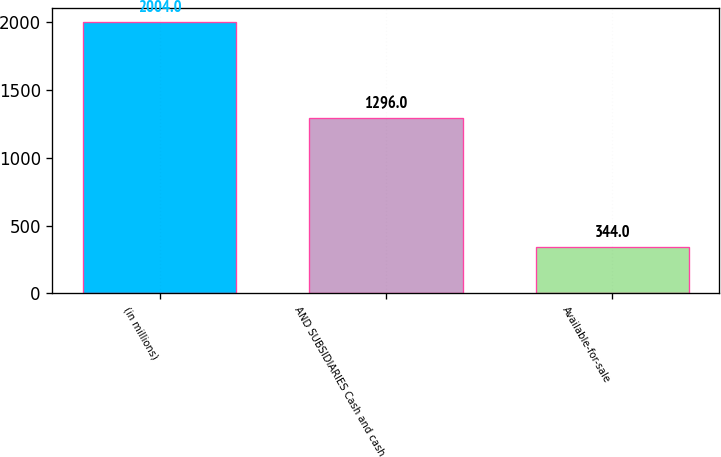<chart> <loc_0><loc_0><loc_500><loc_500><bar_chart><fcel>(in millions)<fcel>AND SUBSIDIARIES Cash and cash<fcel>Available-for-sale<nl><fcel>2004<fcel>1296<fcel>344<nl></chart> 